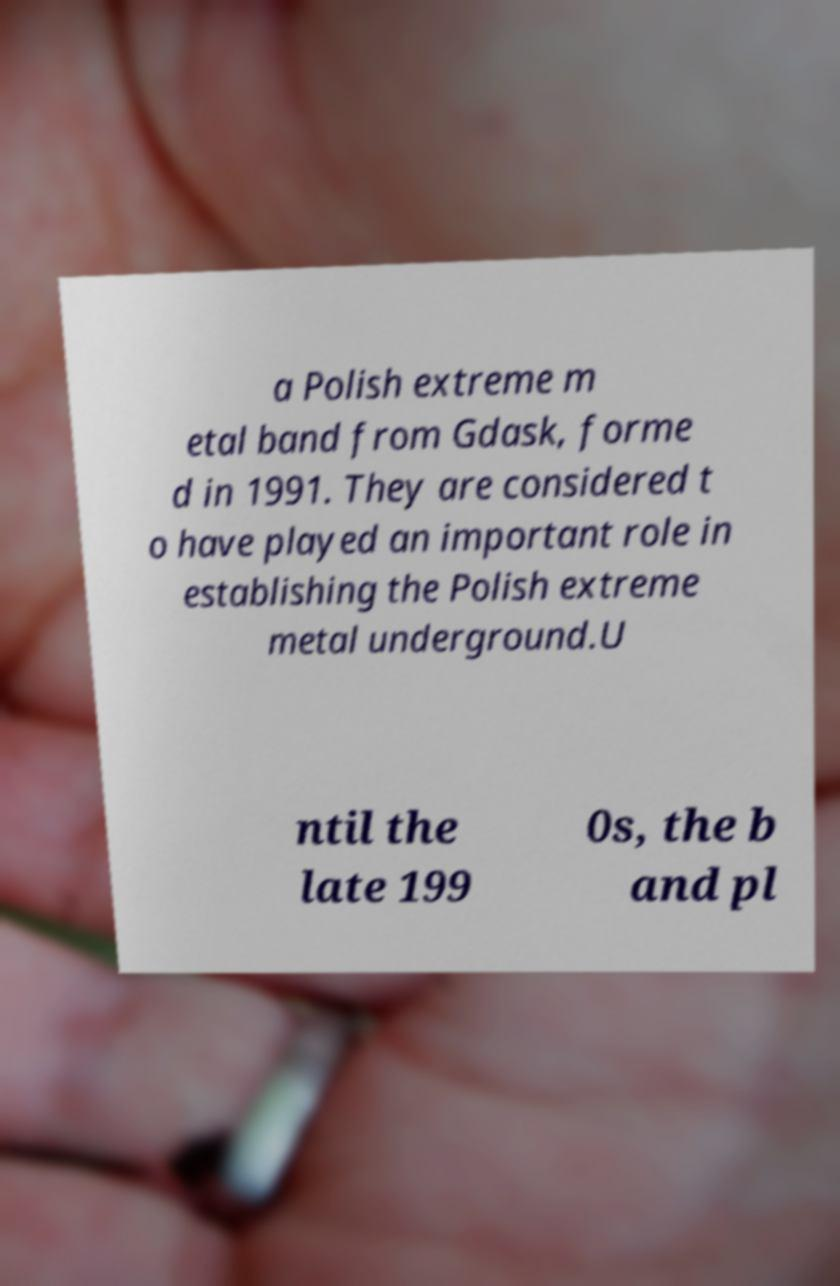Could you assist in decoding the text presented in this image and type it out clearly? a Polish extreme m etal band from Gdask, forme d in 1991. They are considered t o have played an important role in establishing the Polish extreme metal underground.U ntil the late 199 0s, the b and pl 